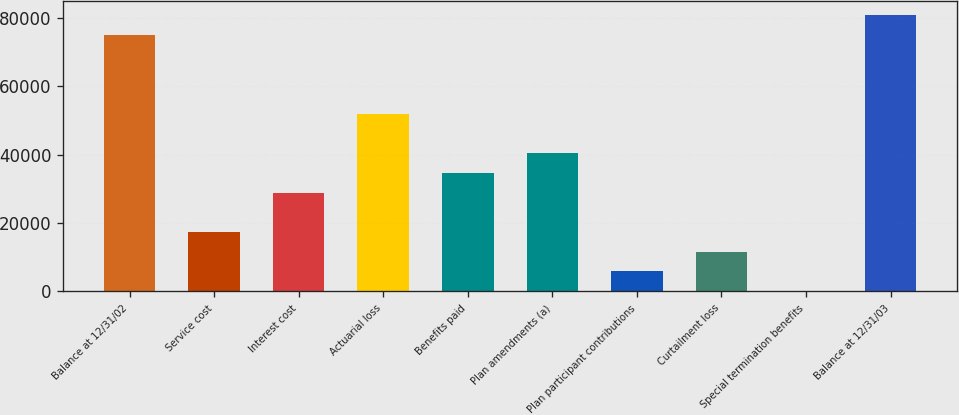Convert chart to OTSL. <chart><loc_0><loc_0><loc_500><loc_500><bar_chart><fcel>Balance at 12/31/02<fcel>Service cost<fcel>Interest cost<fcel>Actuarial loss<fcel>Benefits paid<fcel>Plan amendments (a)<fcel>Plan participant contributions<fcel>Curtailment loss<fcel>Special termination benefits<fcel>Balance at 12/31/03<nl><fcel>75099.9<fcel>17386.9<fcel>28929.5<fcel>52014.7<fcel>34700.8<fcel>40472.1<fcel>5844.3<fcel>11615.6<fcel>73<fcel>80871.2<nl></chart> 